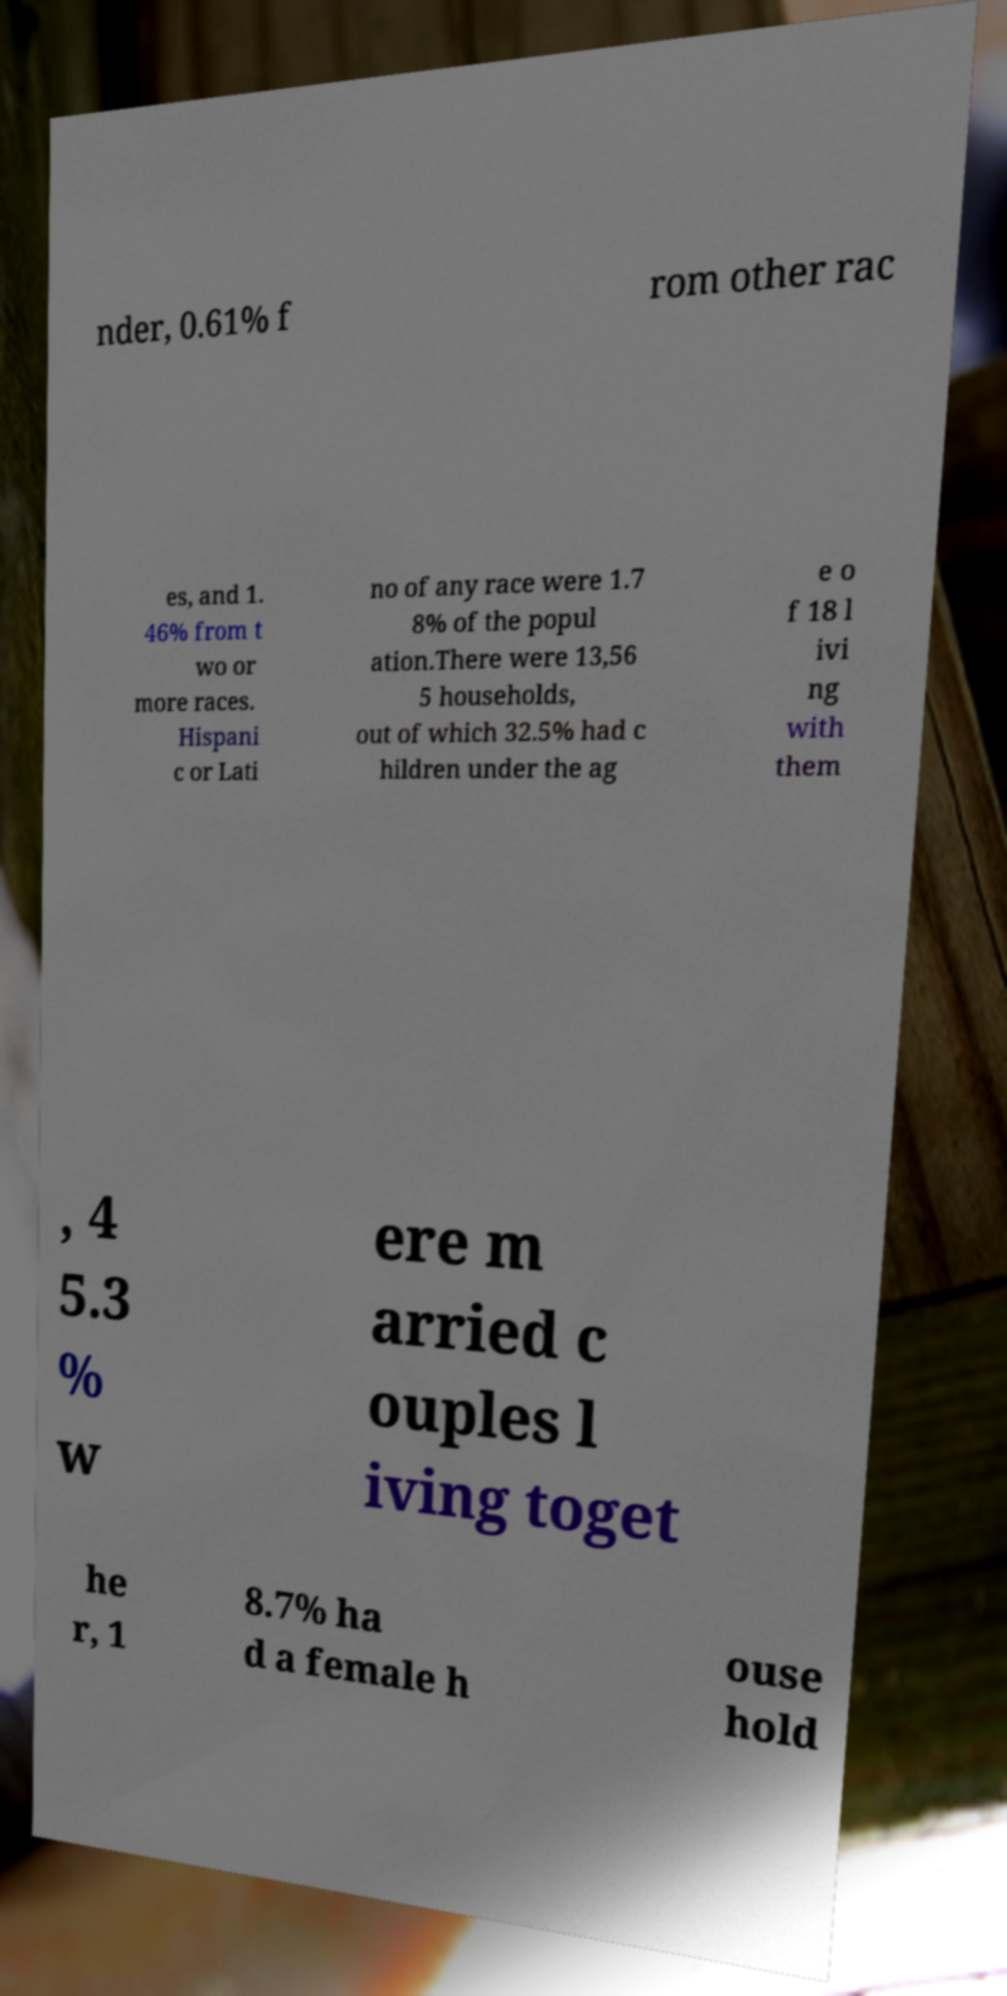Please read and relay the text visible in this image. What does it say? nder, 0.61% f rom other rac es, and 1. 46% from t wo or more races. Hispani c or Lati no of any race were 1.7 8% of the popul ation.There were 13,56 5 households, out of which 32.5% had c hildren under the ag e o f 18 l ivi ng with them , 4 5.3 % w ere m arried c ouples l iving toget he r, 1 8.7% ha d a female h ouse hold 